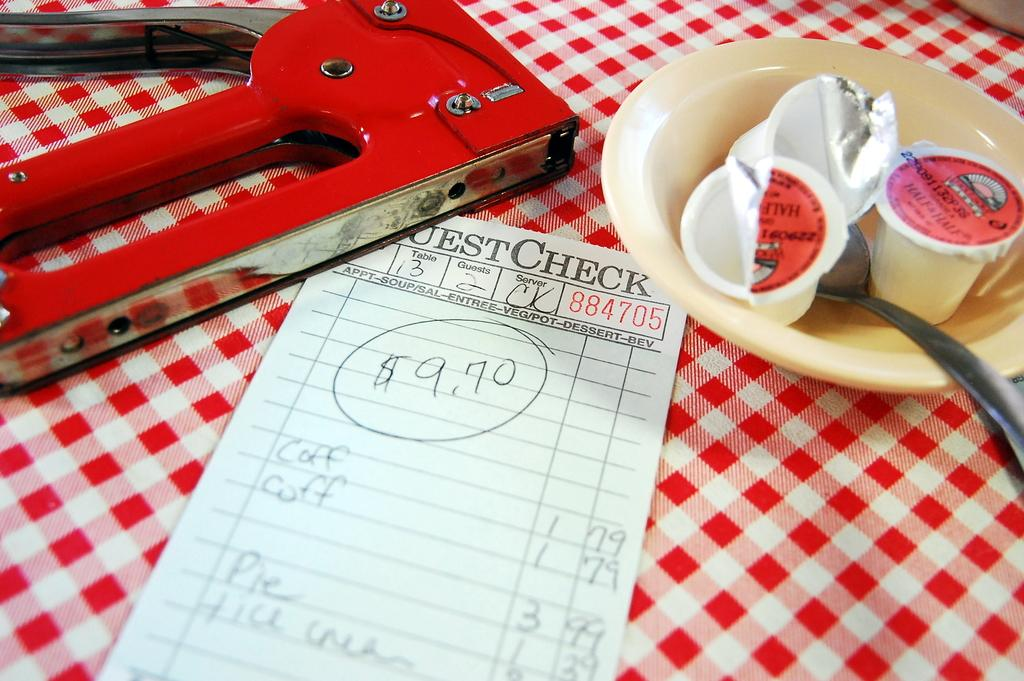Provide a one-sentence caption for the provided image. The guest check cost a total of 9.70 dollars. 